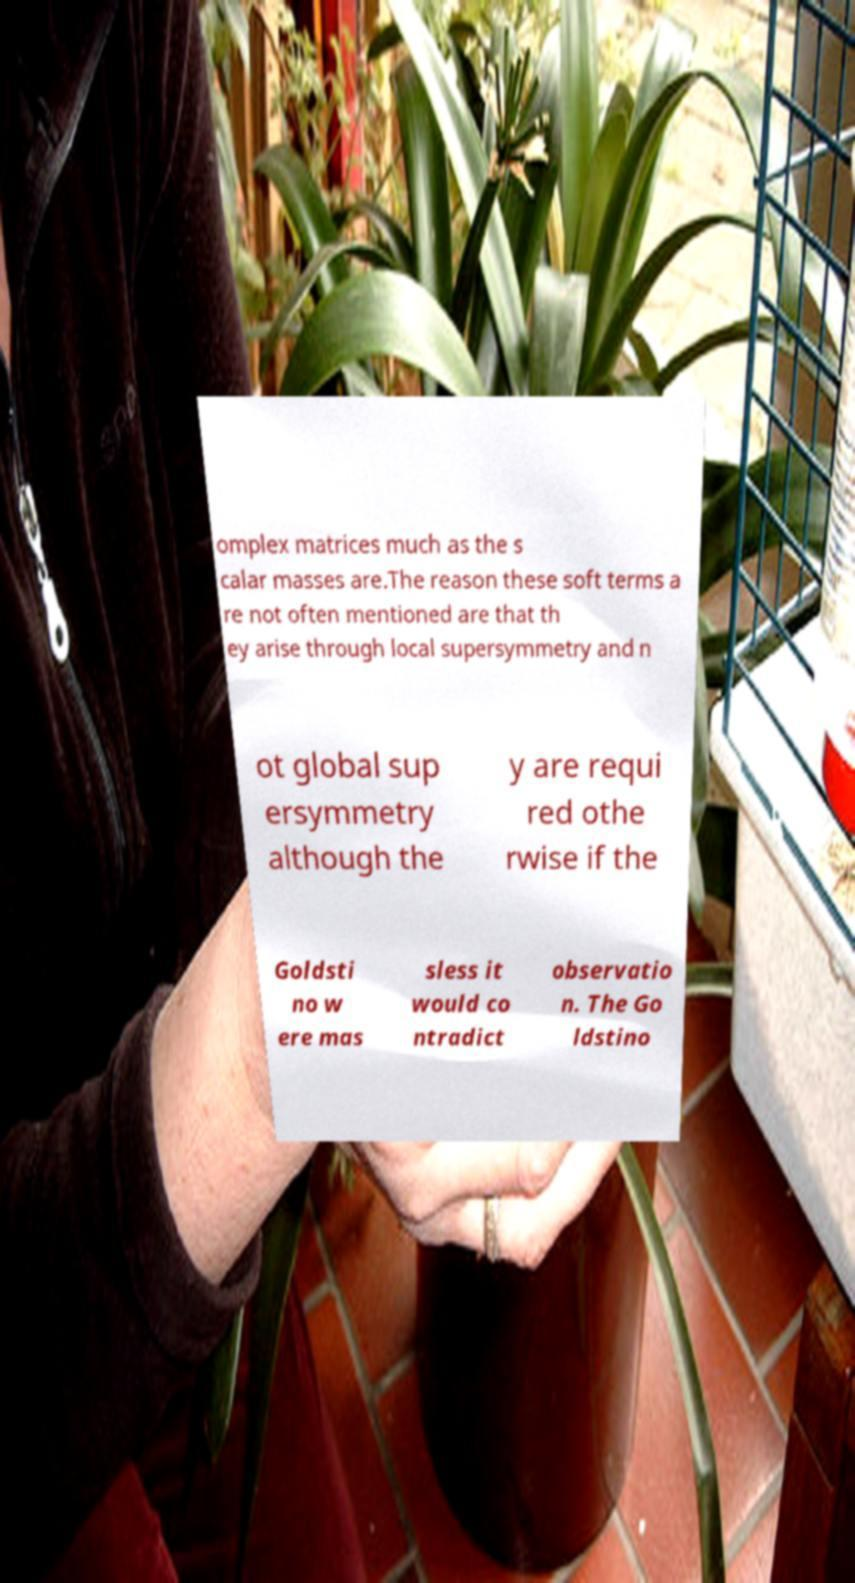For documentation purposes, I need the text within this image transcribed. Could you provide that? omplex matrices much as the s calar masses are.The reason these soft terms a re not often mentioned are that th ey arise through local supersymmetry and n ot global sup ersymmetry although the y are requi red othe rwise if the Goldsti no w ere mas sless it would co ntradict observatio n. The Go ldstino 